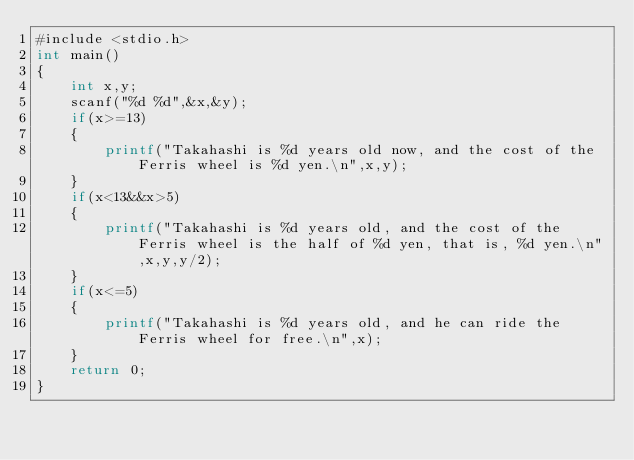<code> <loc_0><loc_0><loc_500><loc_500><_Awk_>#include <stdio.h>
int main()
{
	int x,y;
	scanf("%d %d",&x,&y);
	if(x>=13)
	{
		printf("Takahashi is %d years old now, and the cost of the Ferris wheel is %d yen.\n",x,y);
	}
	if(x<13&&x>5)
	{
		printf("Takahashi is %d years old, and the cost of the Ferris wheel is the half of %d yen, that is, %d yen.\n",x,y,y/2);
	}
	if(x<=5)
	{
		printf("Takahashi is %d years old, and he can ride the Ferris wheel for free.\n",x);
	}
	return 0;
}</code> 